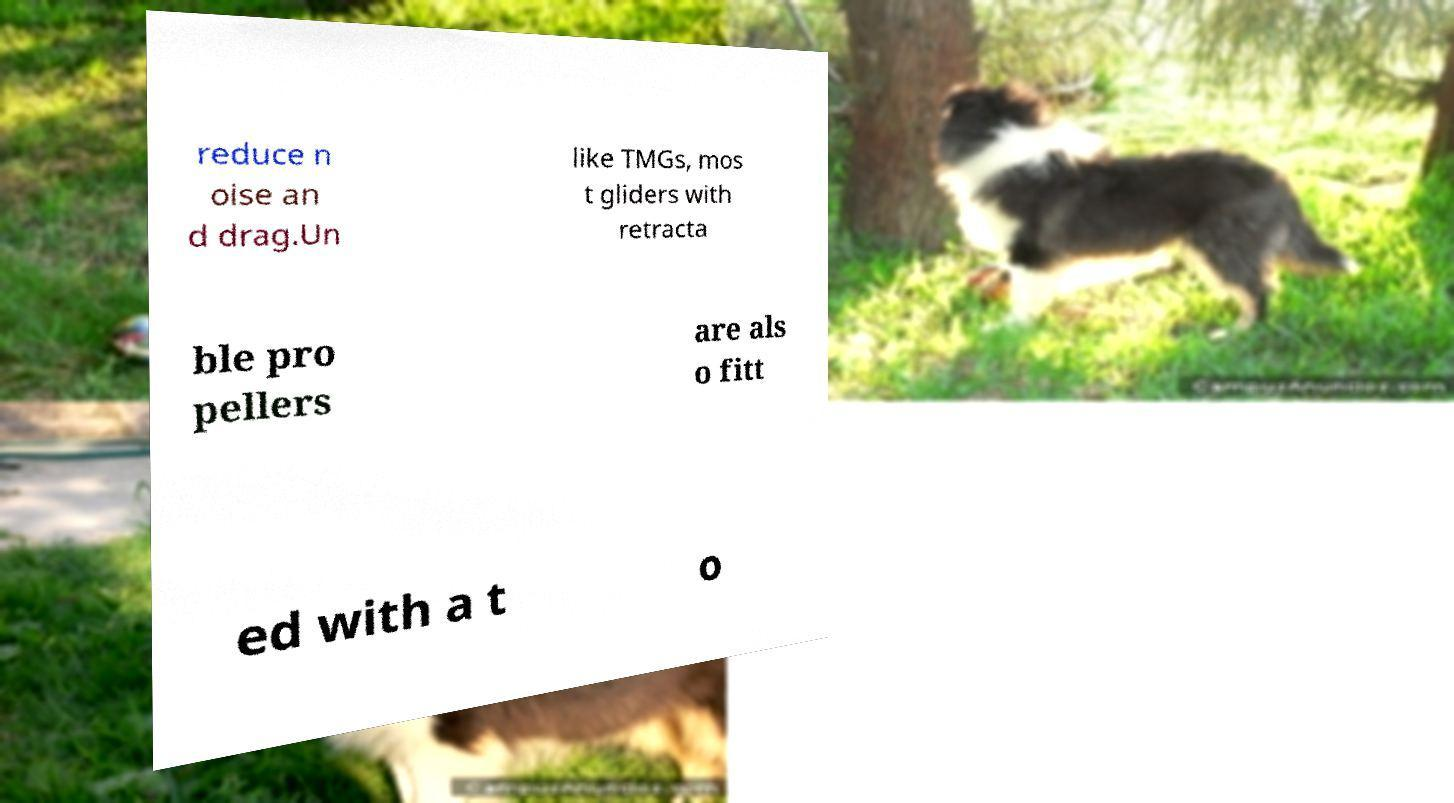There's text embedded in this image that I need extracted. Can you transcribe it verbatim? reduce n oise an d drag.Un like TMGs, mos t gliders with retracta ble pro pellers are als o fitt ed with a t o 